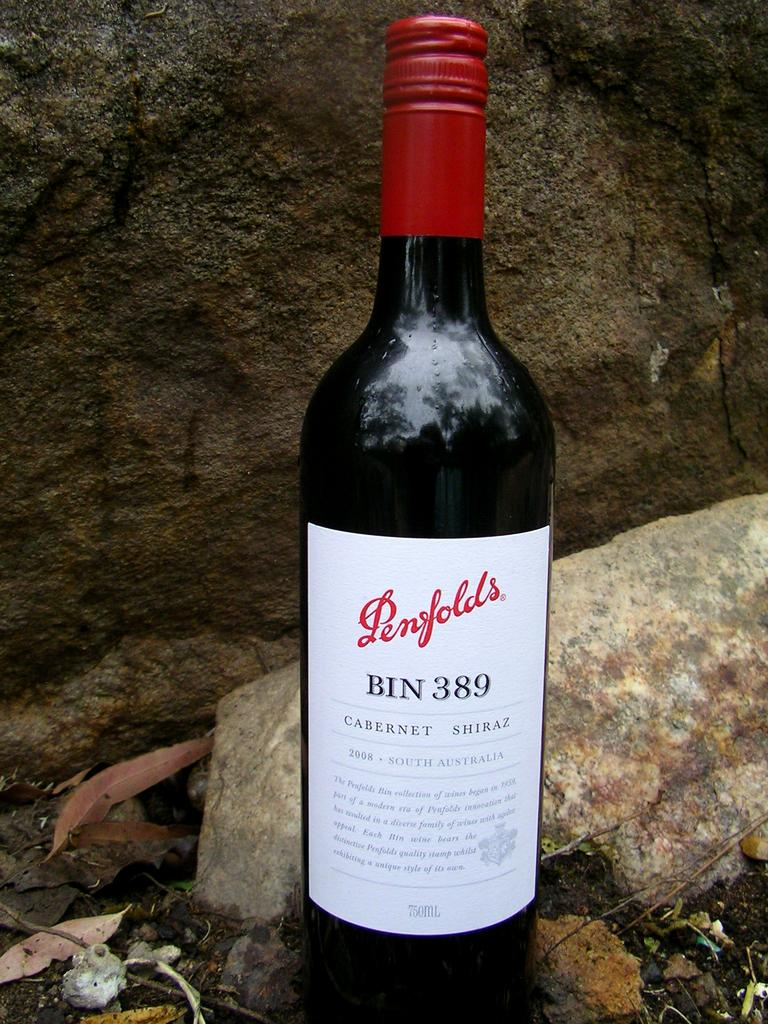<image>
Offer a succinct explanation of the picture presented. The brand of Cabernet was made in South Australia. 